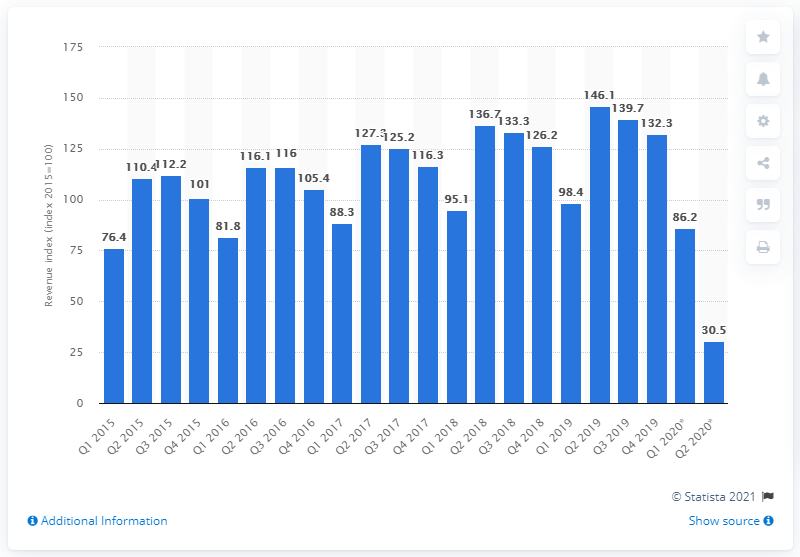Outline some significant characteristics in this image. In the second quarter of 2020, the revenue index of the hotel industry in the Netherlands was 30.5. The revenue index of the hotel industry in the previous quarter was 146.1%. 